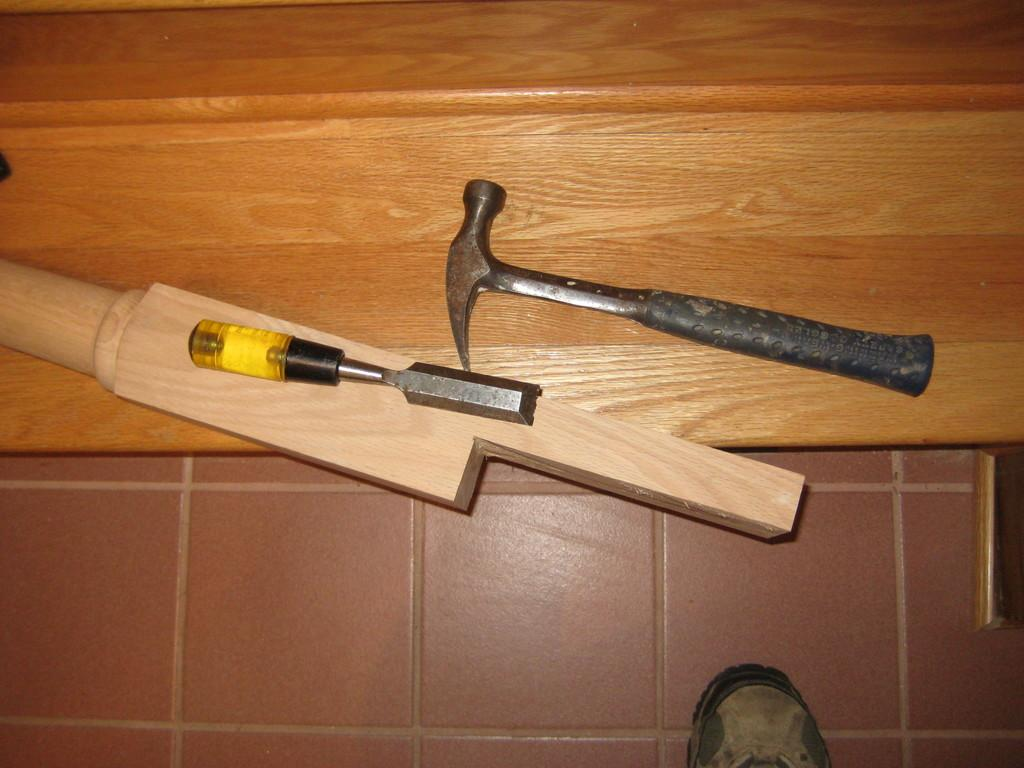What is the main tool visible in the image? There is a hammer in the image. What type of material is the wooden piece made of? The wooden piece is made of wood. What other tools can be seen in the image besides the hammer? There are other tools present in the image. What is the background of the image made of? The background of the image is made of wood. What is the person standing on in the image? The person is standing on the floor in the image. What type of boot is the friend wearing in the image? There is no friend or boot present in the image; it only features a person standing on the floor. 